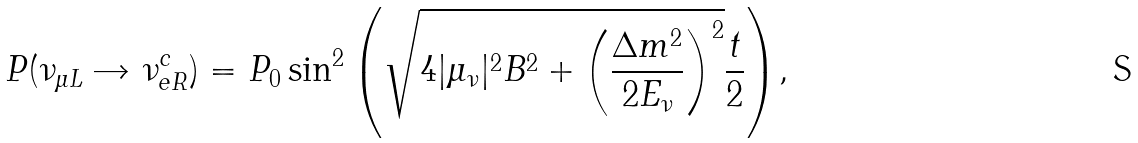<formula> <loc_0><loc_0><loc_500><loc_500>P ( \nu _ { \mu L } \rightarrow \nu _ { e R } ^ { c } ) = P _ { 0 } \sin ^ { 2 } { \left ( \sqrt { 4 | \mu _ { \nu } | ^ { 2 } B ^ { 2 } + \left ( \frac { \Delta m ^ { 2 } } { 2 E _ { \nu } } \right ) ^ { 2 } } \frac { t } { 2 } \right ) } ,</formula> 